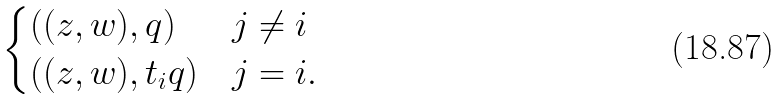Convert formula to latex. <formula><loc_0><loc_0><loc_500><loc_500>\begin{cases} ( ( z , w ) , q ) & j \neq i \\ ( ( z , w ) , t _ { i } q ) & j = i . \\ \end{cases}</formula> 